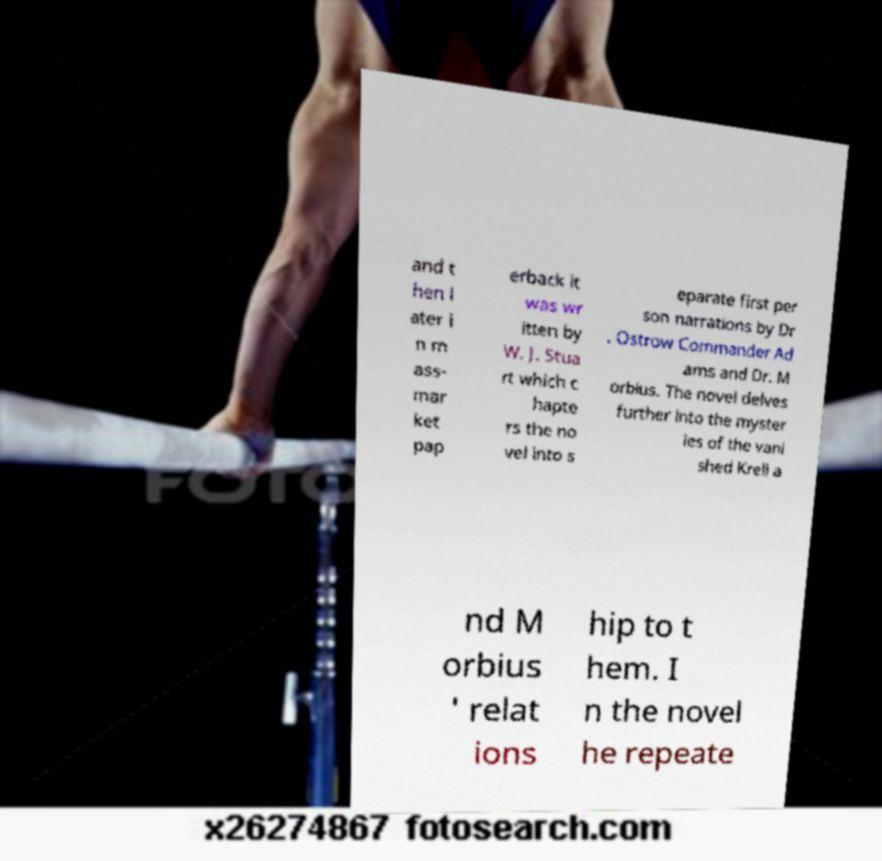For documentation purposes, I need the text within this image transcribed. Could you provide that? and t hen l ater i n m ass- mar ket pap erback it was wr itten by W. J. Stua rt which c hapte rs the no vel into s eparate first per son narrations by Dr . Ostrow Commander Ad ams and Dr. M orbius. The novel delves further into the myster ies of the vani shed Krell a nd M orbius ' relat ions hip to t hem. I n the novel he repeate 